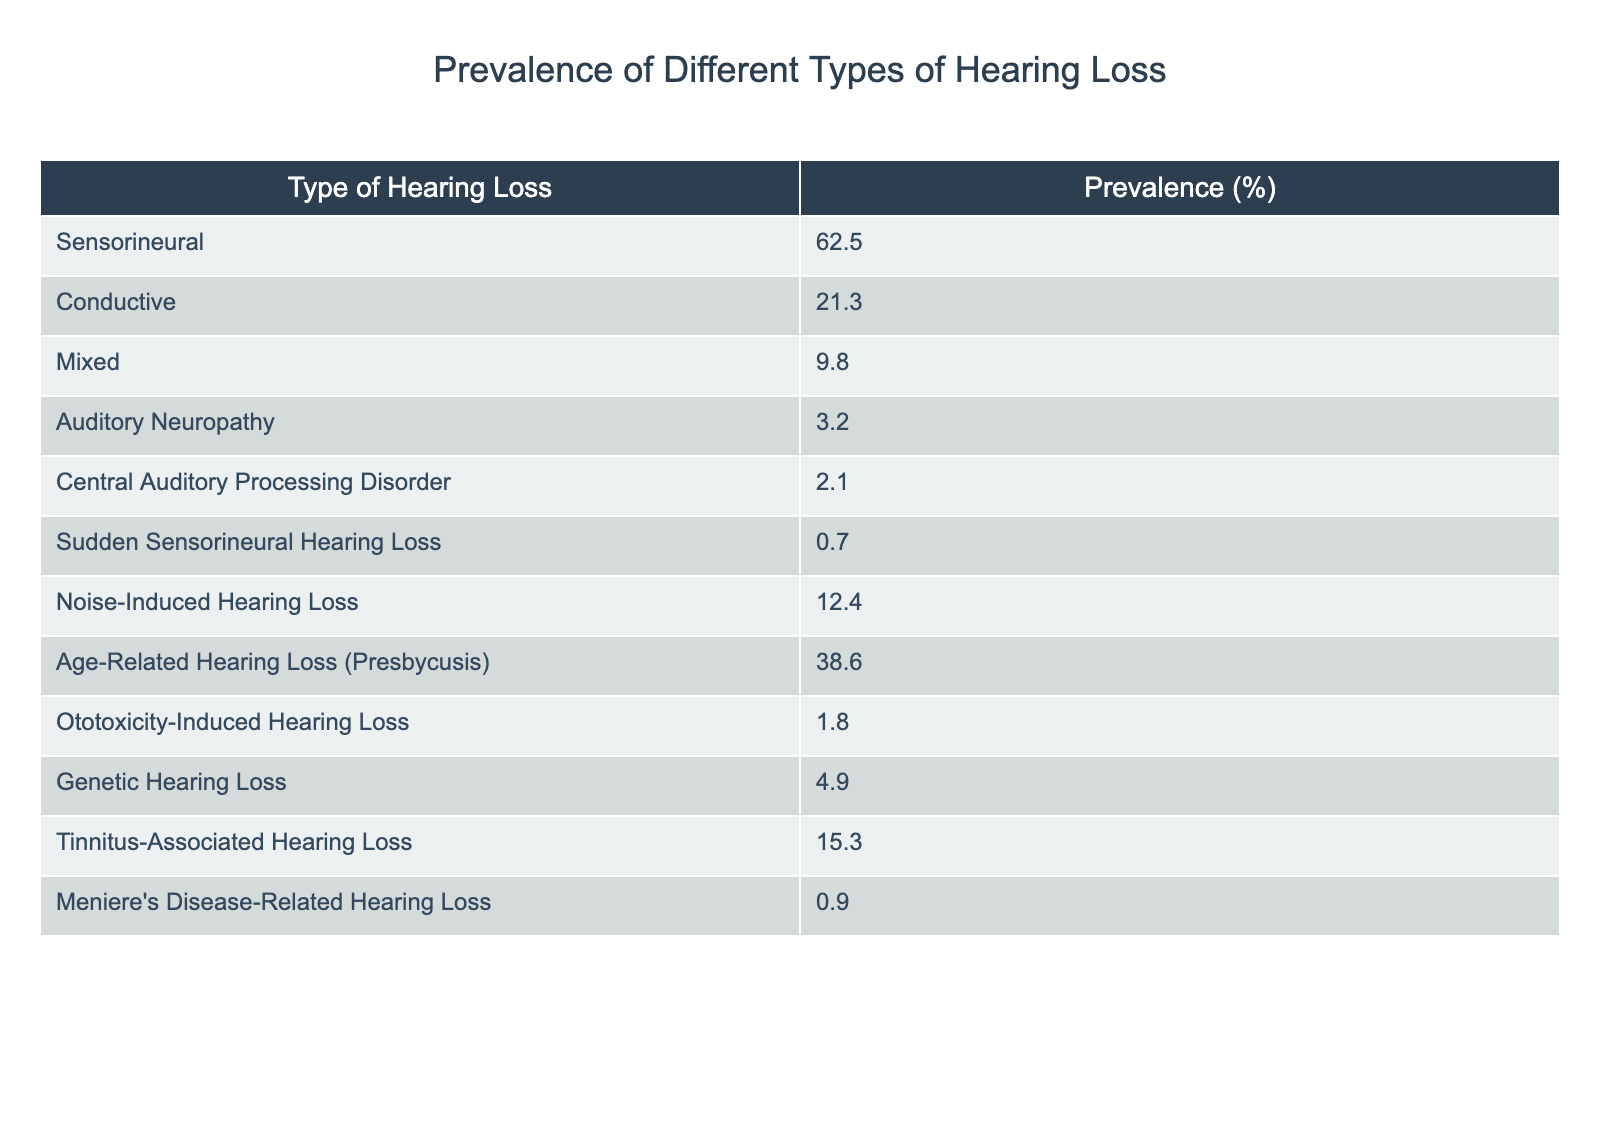What is the prevalence of Sensorineural hearing loss? The table lists the prevalence of Sensorineural hearing loss as 62.5%.
Answer: 62.5% Which type of hearing loss has the lowest prevalence? The lowest prevalence noted in the table is for Sudden Sensorineural Hearing Loss at 0.7%.
Answer: 0.7% What is the combined prevalence of Conductive and Mixed hearing loss? To find this, add the prevalence of Conductive (21.3%) and Mixed (9.8%): 21.3 + 9.8 = 31.1%.
Answer: 31.1% Is Auditory Neuropathy more prevalent than Central Auditory Processing Disorder? Auditory Neuropathy has a prevalence of 3.2%, while Central Auditory Processing Disorder is at 2.1%. Since 3.2% is greater than 2.1%, the answer is yes.
Answer: Yes What percentage of hearing loss types is caused by Noise-Induced Hearing Loss or Tinnitus-Associated Hearing Loss? The prevalence for Noise-Induced Hearing Loss is 12.4% and for Tinnitus-Associated Hearing Loss is 15.3%. Adding these gives 12.4 + 15.3 = 27.7%.
Answer: 27.7% Is the prevalence of Age-Related Hearing Loss greater than the combined prevalence of Ototoxicity-Induced Hearing Loss and Genetic Hearing Loss? Age-Related Hearing Loss has a prevalence of 38.6%, while Ototoxicity-Induced Hearing Loss is 1.8% and Genetic Hearing Loss is 4.9%. Their combined prevalence is 1.8 + 4.9 = 6.7%. Since 38.6% is greater than 6.7%, the answer is yes.
Answer: Yes What is the average prevalence of the types of hearing loss listed in the table? There are 12 types of hearing loss listed. Summing their prevalences gives a total of 170.5%. To find the average, divide by the number of types: 170.5 / 12 = 14.2083, which rounds to approximately 14.21%.
Answer: 14.21% If we exclude the types of hearing loss with a prevalence below 2%, what is the new average? Types below 2% are Sudden Sensorineural Hearing Loss (0.7%) and Meniere's Disease-Related Hearing Loss (0.9%). Excluding these two, the remaining prevalences total 169.9% for 10 types. The new average is 169.9 / 10 = 16.99%.
Answer: 16.99% 